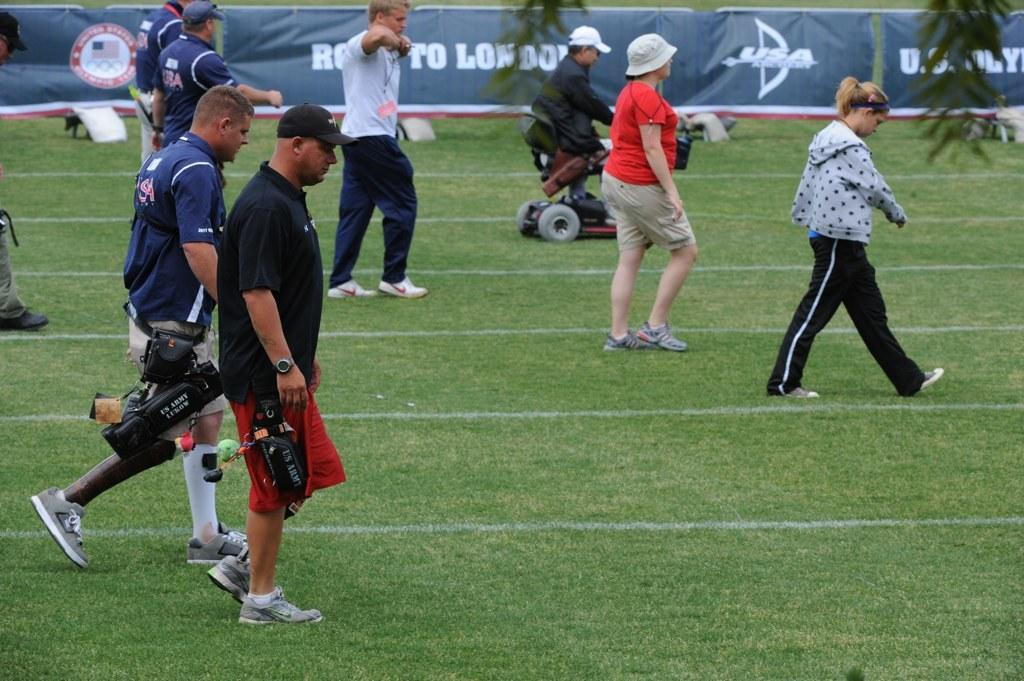Provide a one-sentence caption for the provided image. People standing on a field with the word "USA" in the back. 